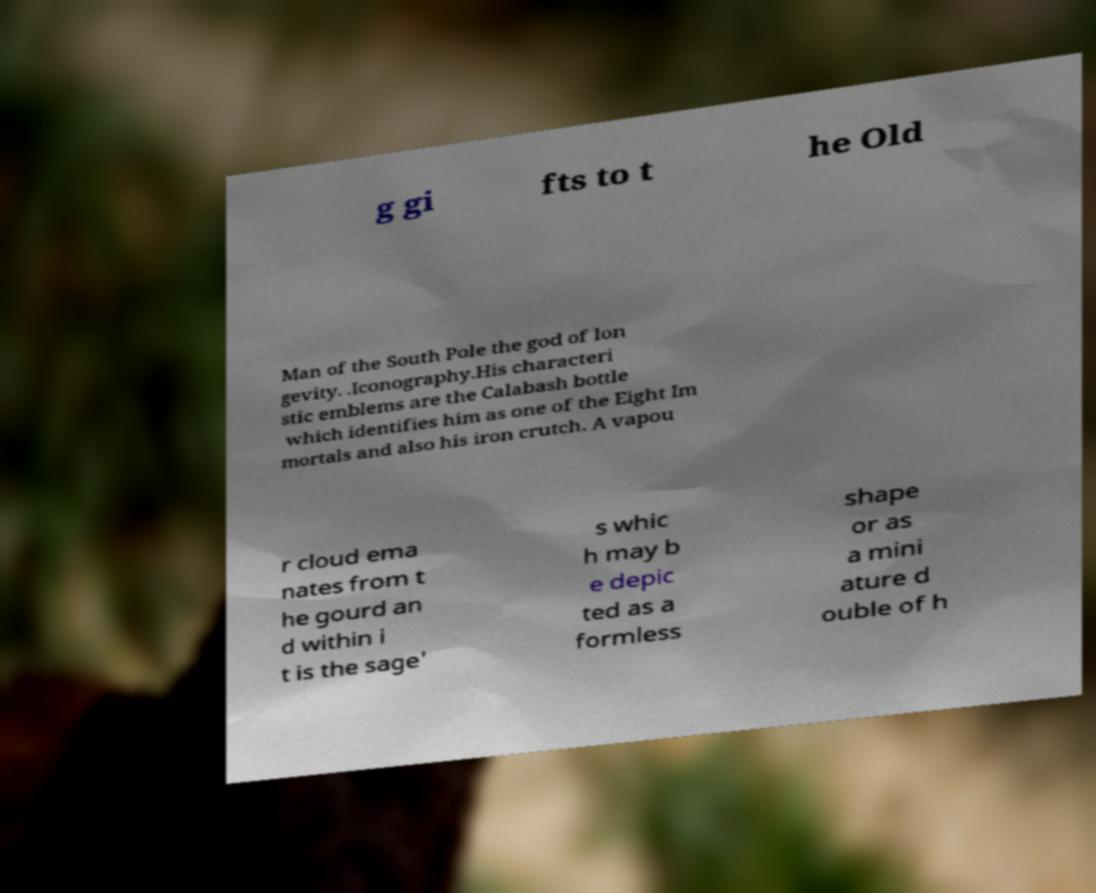For documentation purposes, I need the text within this image transcribed. Could you provide that? g gi fts to t he Old Man of the South Pole the god of lon gevity. .Iconography.His characteri stic emblems are the Calabash bottle which identifies him as one of the Eight Im mortals and also his iron crutch. A vapou r cloud ema nates from t he gourd an d within i t is the sage' s whic h may b e depic ted as a formless shape or as a mini ature d ouble of h 